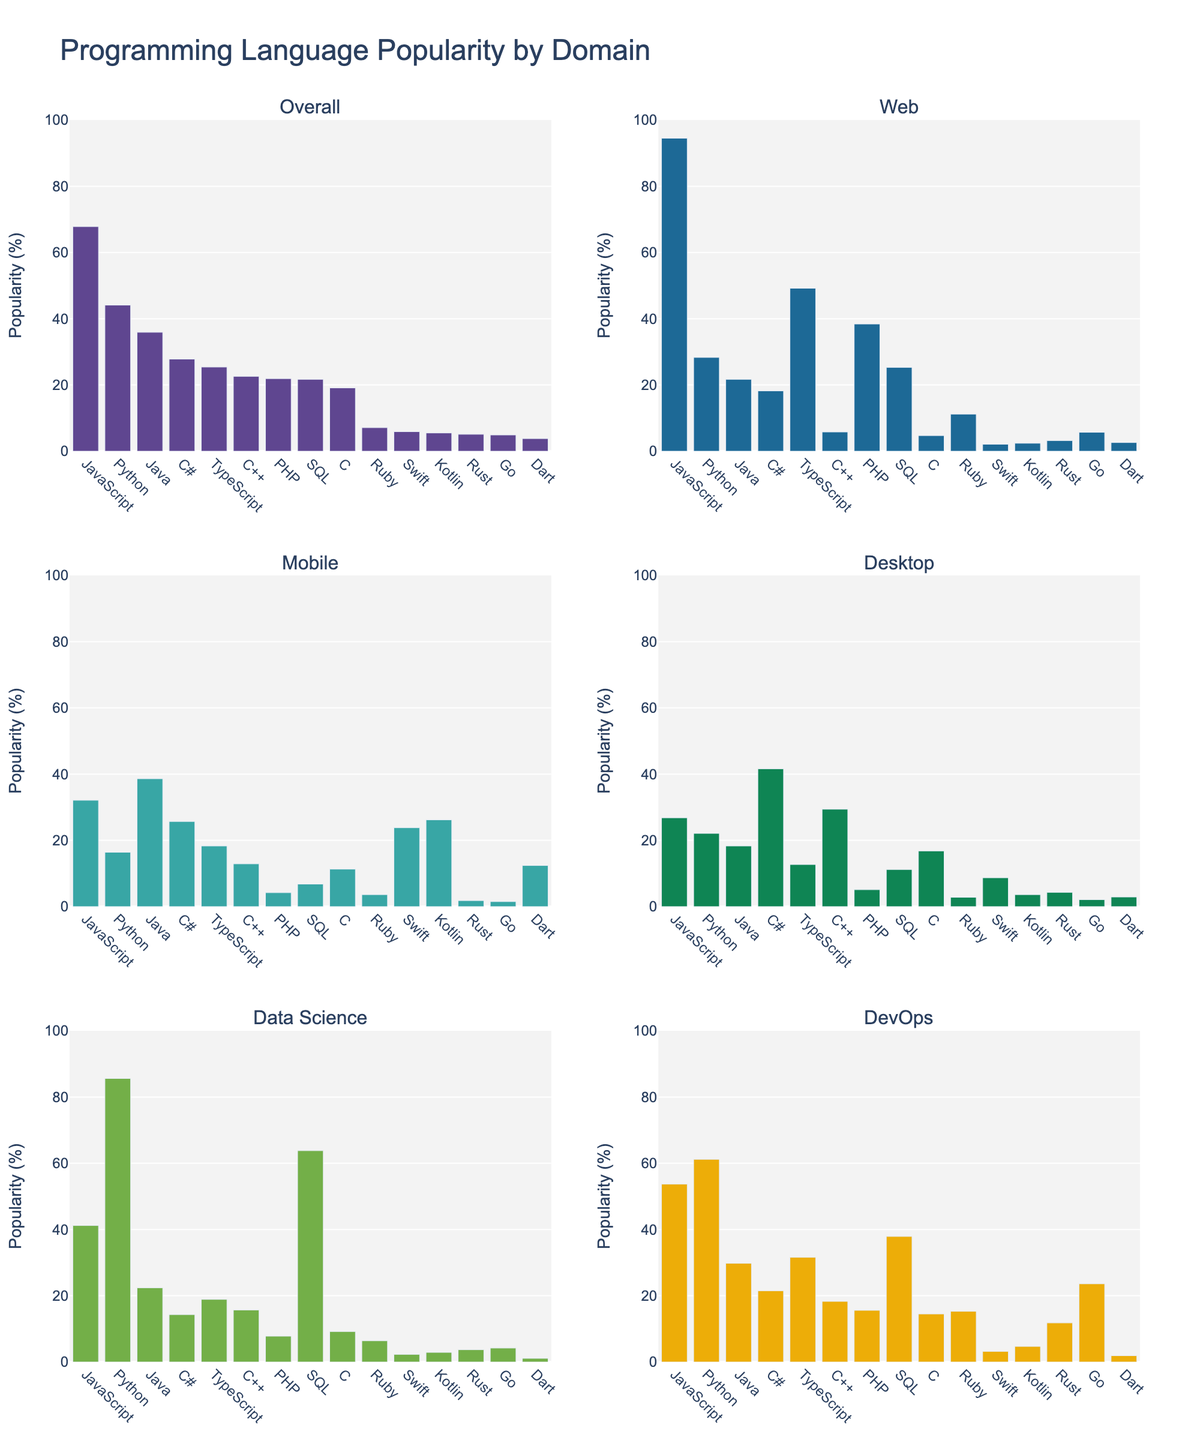What's the most popular language for web development? To determine the most popular language for web development, look at the percentages in the "Web" subplot. The highest percentage will indicate the most popular language. JavaScript stands out with 94.5%.
Answer: JavaScript Which language is least popular overall? To identify the least popular language overall, observe the overall percentages for all languages. The smallest percentage represents the least popular language. Dart has the smallest overall percentage with 3.8%.
Answer: Dart Which two domains have Python as the most popular language? To find these domains, examine where Python has a higher percentage than other languages within their respective subplots. Python is highest in "Data Science" with 85.6% and "DevOps" with 61.2%.
Answer: Data Science, DevOps What is the difference in popularity between Java and Kotlin for mobile development? Look at the percentages for Java and Kotlin in the "Mobile" subplot. Java has 38.6% and Kotlin has 26.2%. Subtract Kotlin's percentage from Java's to get the difference: 38.6% - 26.2% = 12.4%.
Answer: 12.4% Which domain has the highest popularity for C++? To determine this, compare the C++ percentages across all the domains in their respective subplots. C++ has the highest percentage in the "Desktop" domain with 29.4%.
Answer: Desktop How much more popular is SQL in Data Science compared to DevOps? Compare the percentages for SQL in the "Data Science" and "DevOps" subplots. SQL has 63.8% in Data Science and 37.9% in DevOps. Subtract the DevOps percentage from the Data Science percentage: 63.8% - 37.9% = 25.9%.
Answer: 25.9% Among the top three languages in overall popularity, which one is least popular in mobile development? First, identify the top three languages overall: JavaScript (67.8%), Python (44.1%), and Java (35.9%). Then check these languages' percentages in the "Mobile" subplot. JavaScript (32.1%), Python (16.4%), Java (38.6%). Python has the least mobile popularity out of the three.
Answer: Python Which language has the most even distribution across all domains? To find this, look for the language with the least fluctuation in percentages across all domains. Calculate the variance of percentages across the domains for each language. C# has relatively balanced percentages: 18.2%, 25.7%, 41.6%, 14.3%, 21.5%.
Answer: C# What is the total popularity percentage for TypeScript across all domains? Sum the percentages of TypeScript across the six domains: 49.2% (Web) + 18.3% (Mobile) + 12.7% (Desktop) + 18.9% (Data Science) + 31.6% (DevOps) = 130.7%.
Answer: 130.7% 